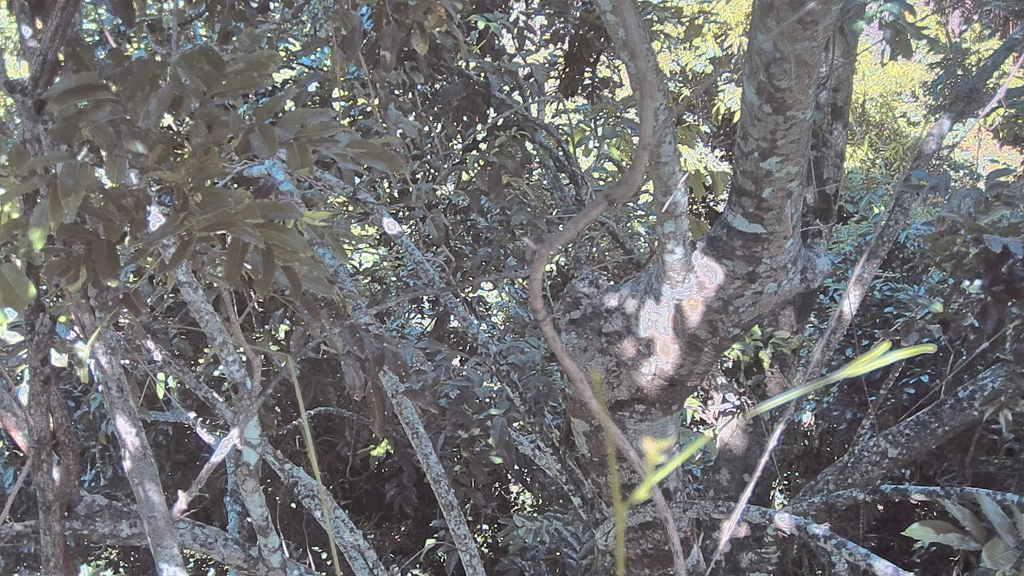What type of vegetation can be seen in the image? There are trees in the image. How does the behavior of the balloon affect the growth of the trees in the image? There is no balloon present in the image, so its behavior cannot affect the growth of the trees. 